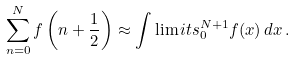Convert formula to latex. <formula><loc_0><loc_0><loc_500><loc_500>\sum _ { n = 0 } ^ { N } f \left ( n + \frac { 1 } { 2 } \right ) \approx \int \lim i t s _ { 0 } ^ { N + 1 } f ( x ) \, d x \, .</formula> 